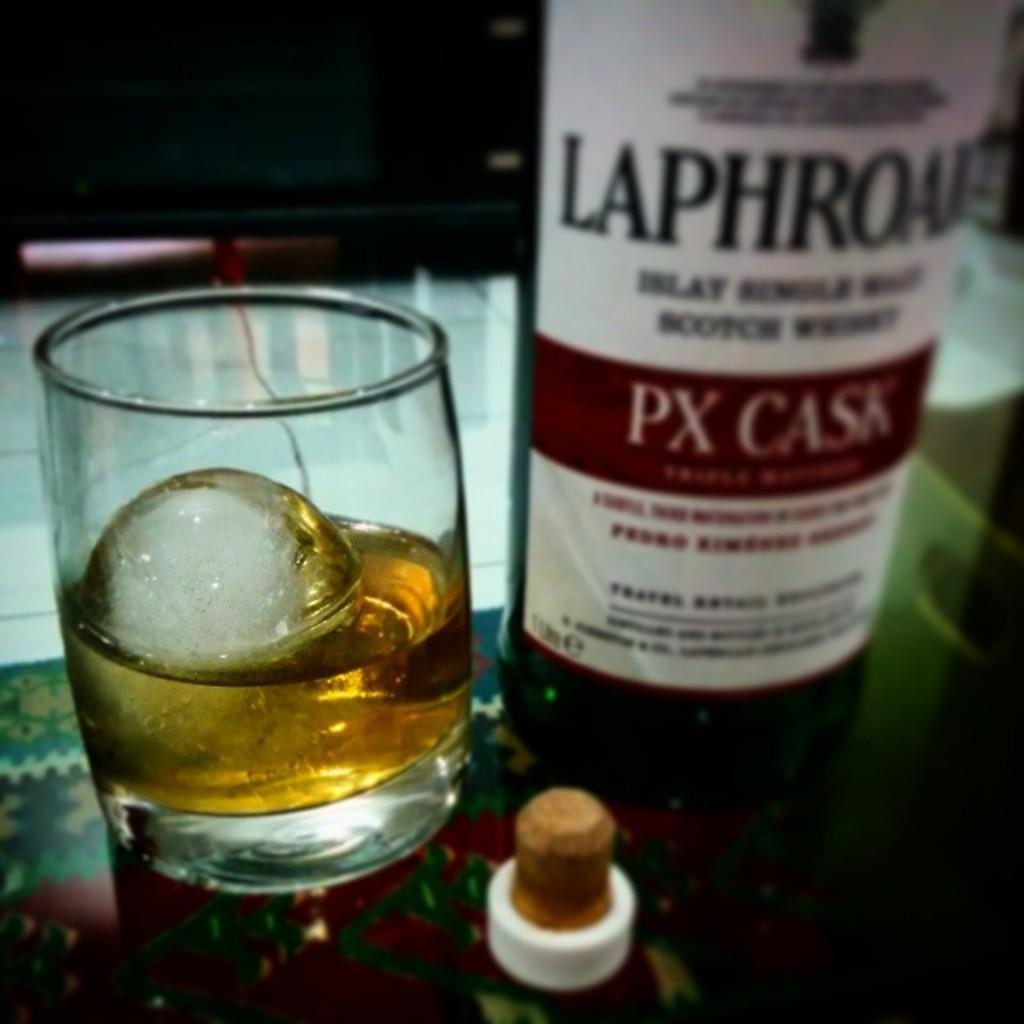<image>
Describe the image concisely. A bottle of PX cask next to a glass with an ice cube in it. 